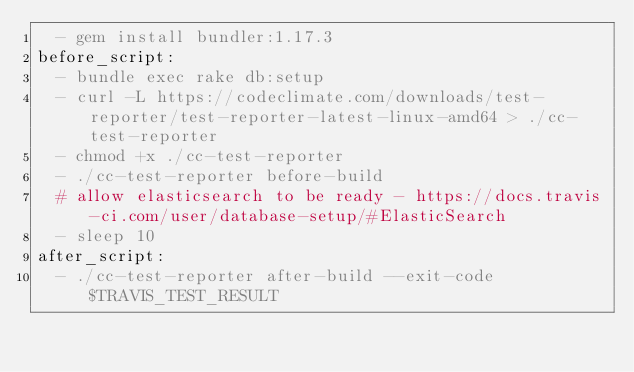Convert code to text. <code><loc_0><loc_0><loc_500><loc_500><_YAML_>  - gem install bundler:1.17.3
before_script:
  - bundle exec rake db:setup
  - curl -L https://codeclimate.com/downloads/test-reporter/test-reporter-latest-linux-amd64 > ./cc-test-reporter
  - chmod +x ./cc-test-reporter
  - ./cc-test-reporter before-build
  # allow elasticsearch to be ready - https://docs.travis-ci.com/user/database-setup/#ElasticSearch
  - sleep 10
after_script:
  - ./cc-test-reporter after-build --exit-code $TRAVIS_TEST_RESULT
</code> 